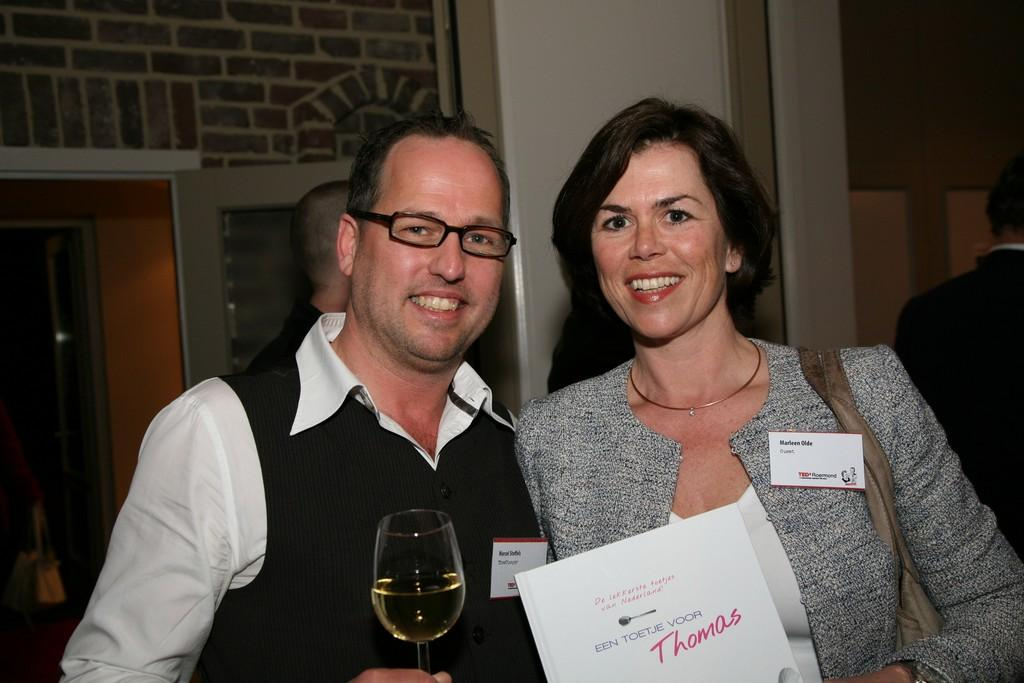<image>
Relay a brief, clear account of the picture shown. The persons name on the right is Marleen Olde 